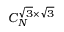<formula> <loc_0><loc_0><loc_500><loc_500>C _ { N } ^ { \sqrt { 3 } \times \sqrt { 3 } }</formula> 